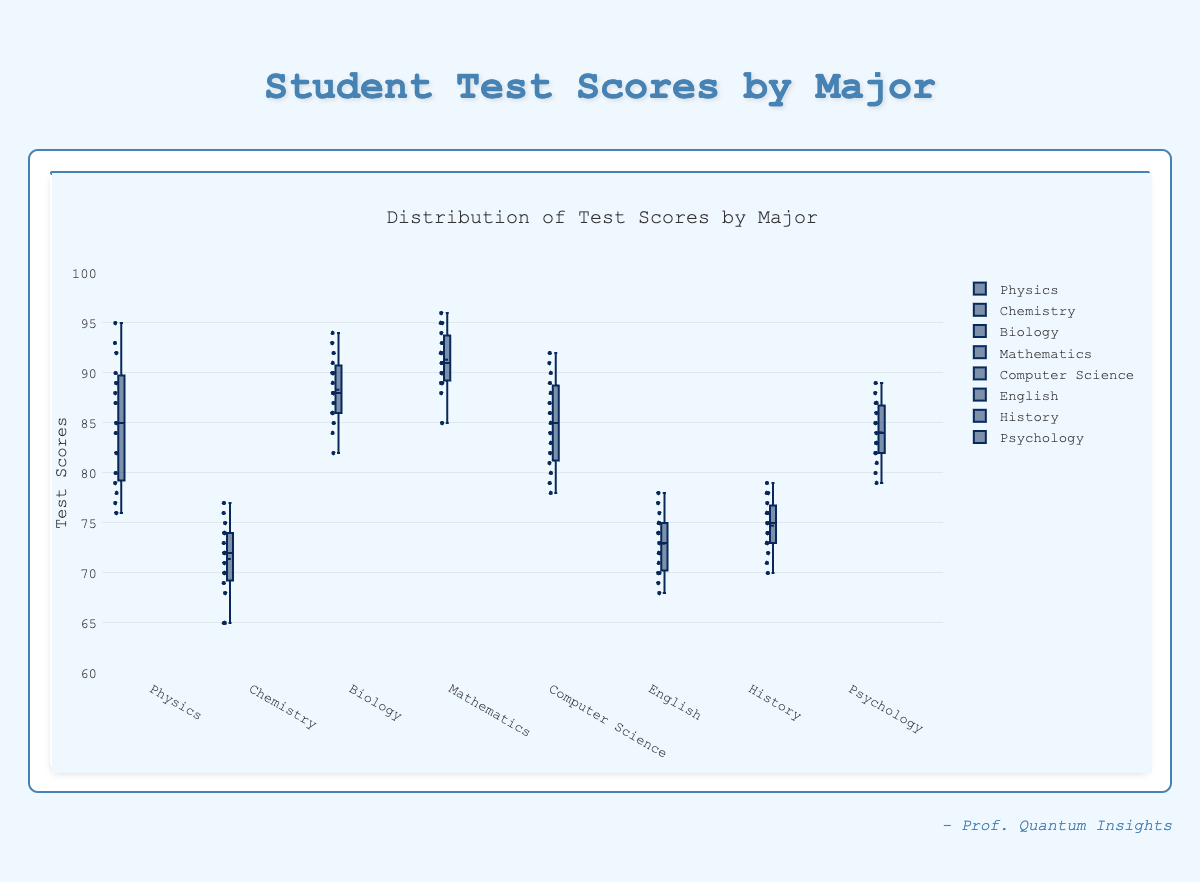What is the title of the figure? The title is displayed prominently at the top of the figure and reads "Distribution of Test Scores by Major".
Answer: Distribution of Test Scores by Major What is the median test score for Biology majors? The median is represented by the line inside the box. For Biology majors, it appears around 88.
Answer: 88 Which major has the highest median test score? By comparing the medians (central lines in each box), Mathematics has the highest median score, which is around 91.
Answer: Mathematics How does the range of test scores for Chemistry compare to that of Mathematics? The range is the difference between the lowest and highest points. Chemistry ranges from 65 to 77, while Mathematics ranges from 85 to 96. Chemistry has a smaller range (12) than Mathematics (11).
Answer: Chemistry has a smaller range than Mathematics Which major has the smallest interquartile range (IQR)? IQR is the range between the first quartile (Q1) and the third quartile (Q3). Physics has the smallest IQR, as its box is the narrowest.
Answer: Physics What is the outlier status for the Physics test scores? Outliers are often shown as individual points outside the whiskers. There are no outliers for Physics as all points fall within the whiskers.
Answer: No outliers Compare the mean test scores of Computer Science and History majors. The mean is often shown with a dot or small line. In both Computer Science and History, the mean falls in the middle of the boxes but slightly lower for History. Computer Science has a higher mean.
Answer: Computer Science has a higher mean Which major has the most spread in test scores? The spread is indicated by the length of the whiskers. Biology shows the most spread from the minimum to the maximum score, ranging from about 82 to 94.
Answer: Biology How does the median score of Computer Science majors compare to that of Psychology majors? The median for Computer Science majors (around 85) is slightly lower than that for Psychology majors (around 85).
Answer: Slightly lower 